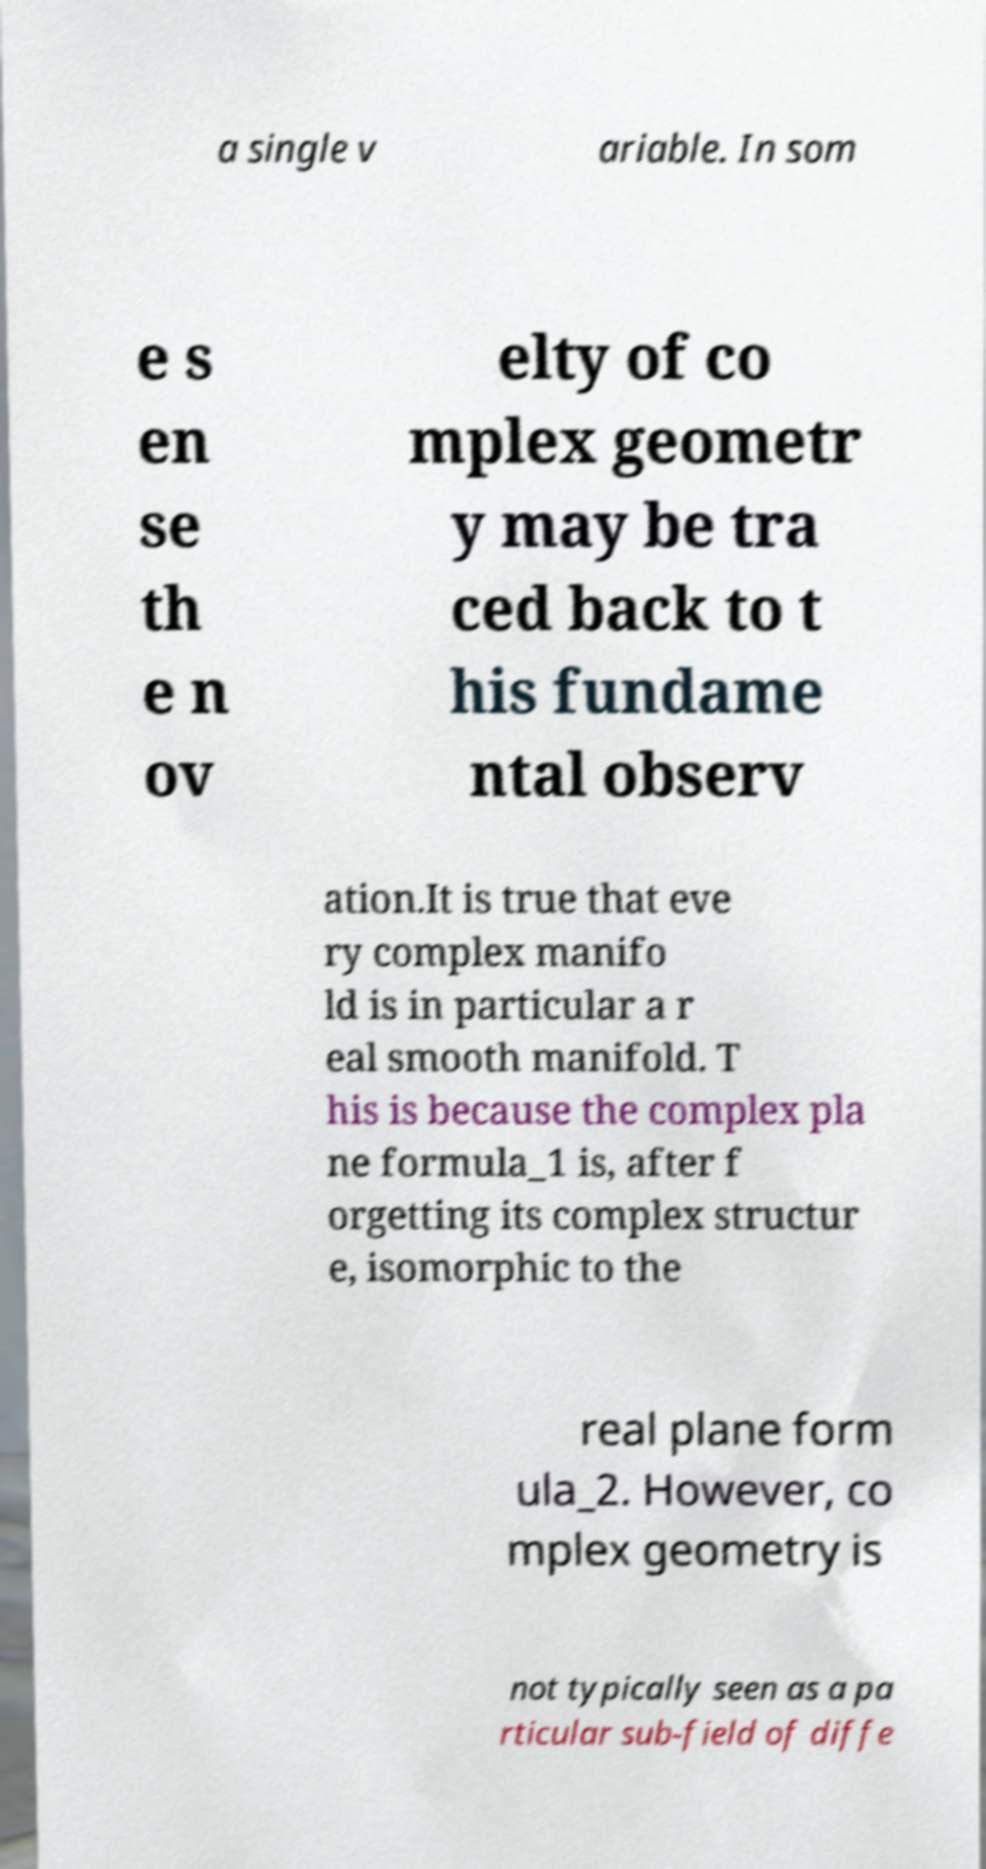Can you accurately transcribe the text from the provided image for me? a single v ariable. In som e s en se th e n ov elty of co mplex geometr y may be tra ced back to t his fundame ntal observ ation.It is true that eve ry complex manifo ld is in particular a r eal smooth manifold. T his is because the complex pla ne formula_1 is, after f orgetting its complex structur e, isomorphic to the real plane form ula_2. However, co mplex geometry is not typically seen as a pa rticular sub-field of diffe 